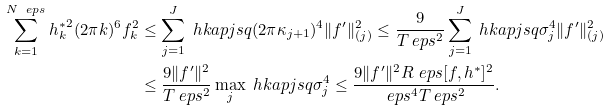Convert formula to latex. <formula><loc_0><loc_0><loc_500><loc_500>\sum _ { k = 1 } ^ { N _ { \ } e p s } { h _ { k } ^ { * } } ^ { 2 } ( 2 \pi k ) ^ { 6 } f _ { k } ^ { 2 } & \leq \sum _ { j = 1 } ^ { J } \ h k a p j s q ( 2 \pi \kappa _ { j + 1 } ) ^ { 4 } \| f ^ { \prime } \| _ { ( j ) } ^ { 2 } \leq \frac { 9 } { T _ { \ } e p s ^ { 2 } } \sum _ { j = 1 } ^ { J } \ h k a p j s q \sigma _ { j } ^ { 4 } \| f ^ { \prime } \| _ { ( j ) } ^ { 2 } \\ & \leq \frac { 9 \| f ^ { \prime } \| ^ { 2 } } { T _ { \ } e p s ^ { 2 } } \max _ { j } \ h k a p j s q \sigma _ { j } ^ { 4 } \leq \frac { 9 \| f ^ { \prime } \| ^ { 2 } R ^ { \ } e p s [ f , h ^ { * } ] ^ { 2 } } { \ e p s ^ { 4 } T _ { \ } e p s ^ { 2 } } .</formula> 